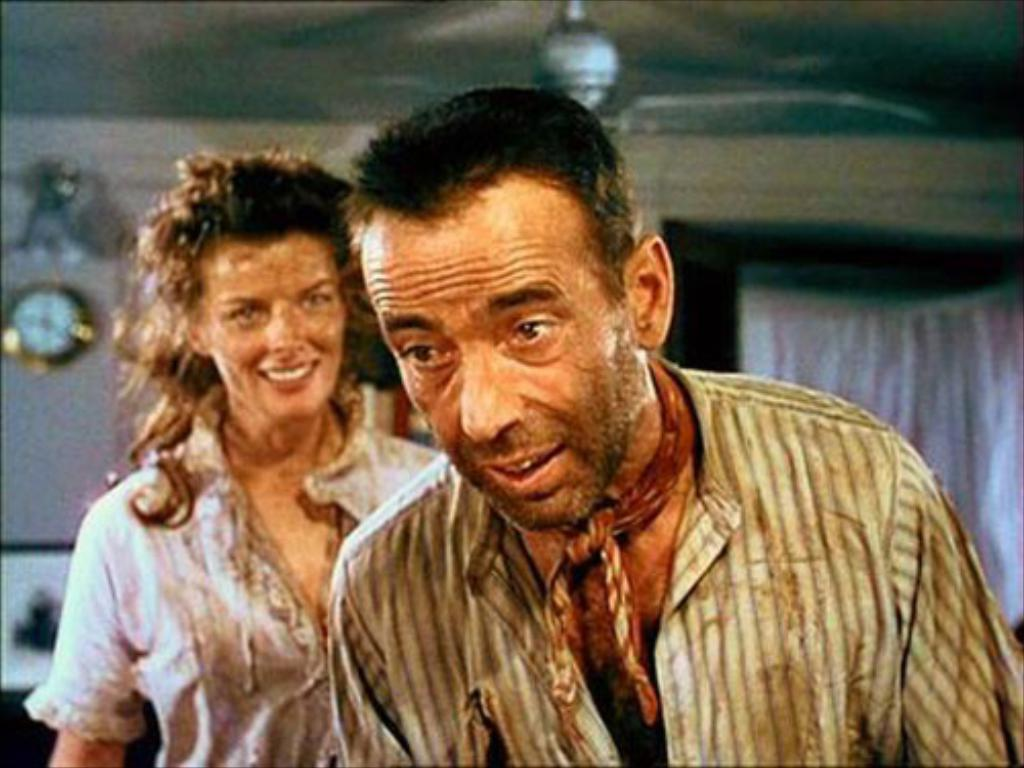How many people are present in the image? There are two persons in the image. What objects can be seen in the image besides the people? There is a wall clock and a fan in the image. What sense is being used by the persons in the image? The provided facts do not give information about the senses being used by the persons in the image. 